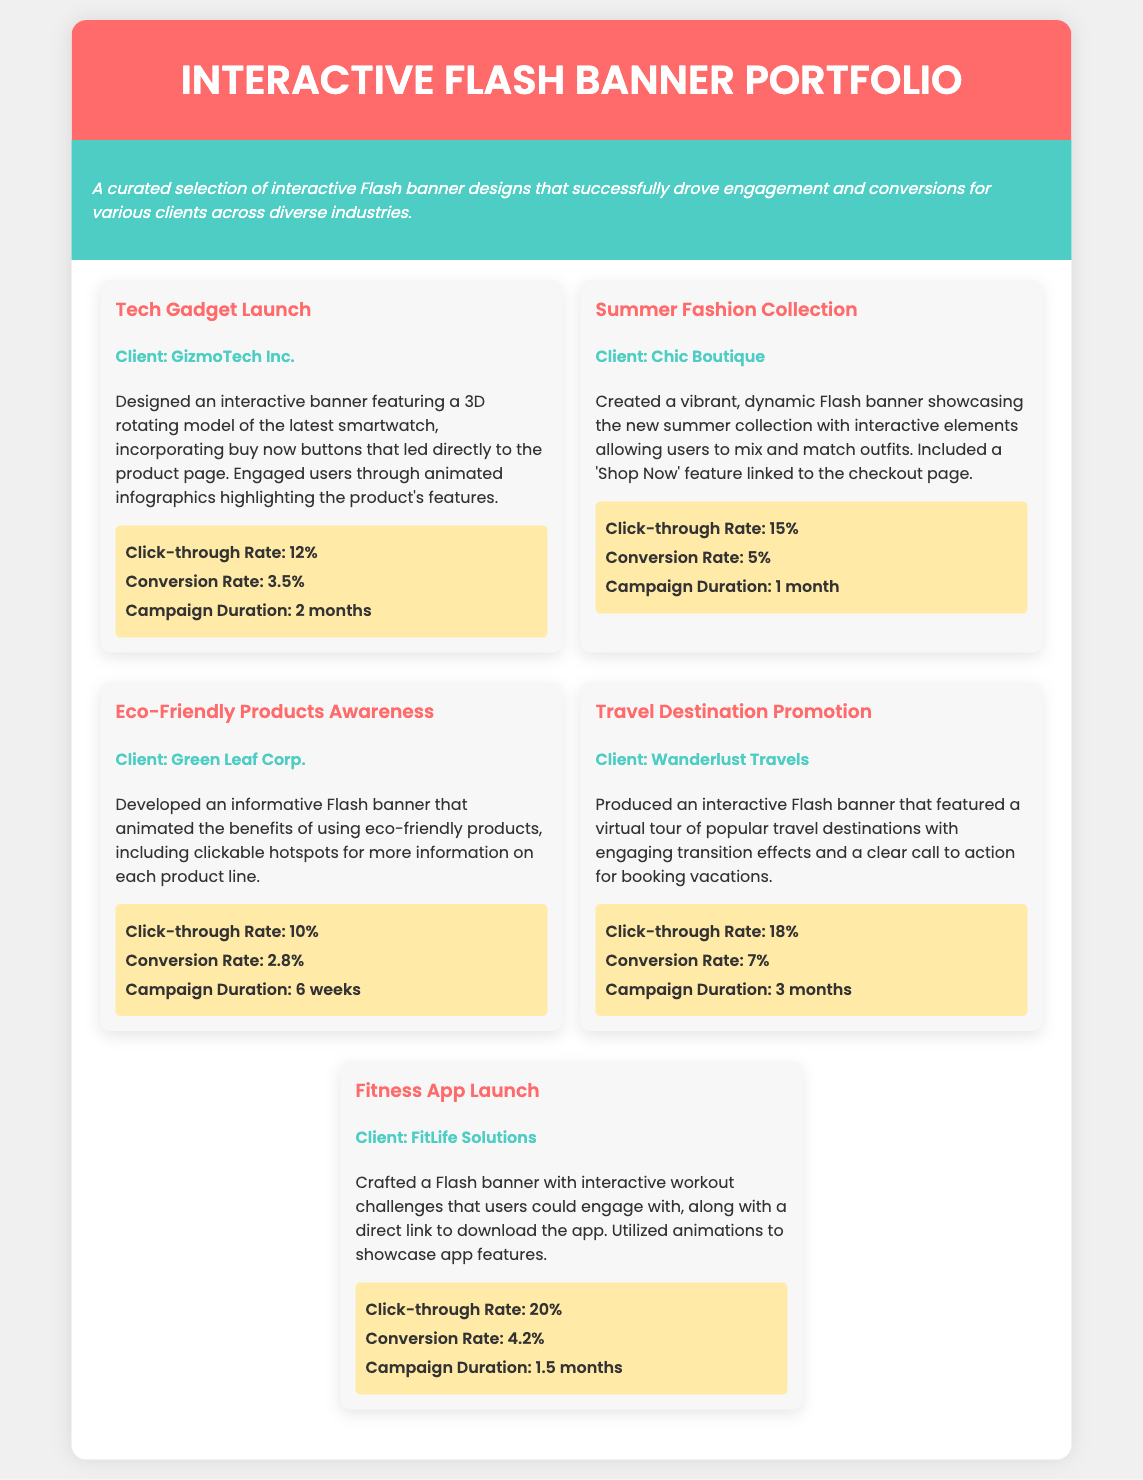What is the title of the portfolio? The title of the portfolio is presented prominently at the top of the document.
Answer: Interactive Flash Banner Portfolio Who is the client for the Tech Gadget Launch project? The client's name is associated with the specific project mentioned in the document.
Answer: GizmoTech Inc What was the click-through rate for the Summer Fashion Collection campaign? The click-through rate is provided in the outcomes section for the relevant project.
Answer: 15% How long did the Travel Destination Promotion campaign run? The campaign duration is mentioned in the outcomes section for each project.
Answer: 3 months What interactive feature was included in the Fitness App Launch banner? The interactive feature includes elements highlighted in the project description.
Answer: Interactive workout challenges Which campaign had the highest conversion rate? By comparing the conversion rates listed in the outcomes of each project, the highest value can be identified.
Answer: Travel Destination Promotion How many projects are showcased in the portfolio? The number of project entries can be counted from the displayed project sections.
Answer: 5 What color is the header background? The background color of the header is defined in the styling of the document.
Answer: #ff6b6b What feature was used in the Eco-Friendly Products Awareness banner? The description provides specific interactive elements included in the banner design.
Answer: Clickable hotspots 